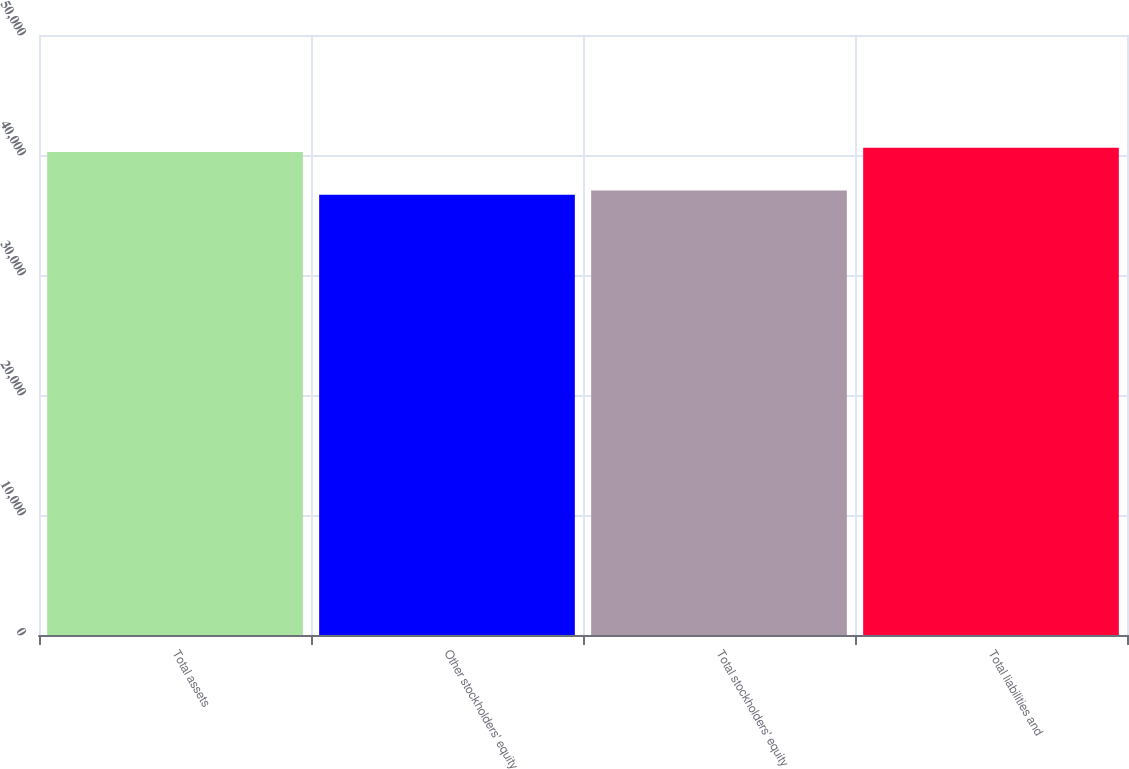Convert chart. <chart><loc_0><loc_0><loc_500><loc_500><bar_chart><fcel>Total assets<fcel>Other stockholders' equity<fcel>Total stockholders' equity<fcel>Total liabilities and<nl><fcel>40257<fcel>36684<fcel>37041.3<fcel>40614.3<nl></chart> 